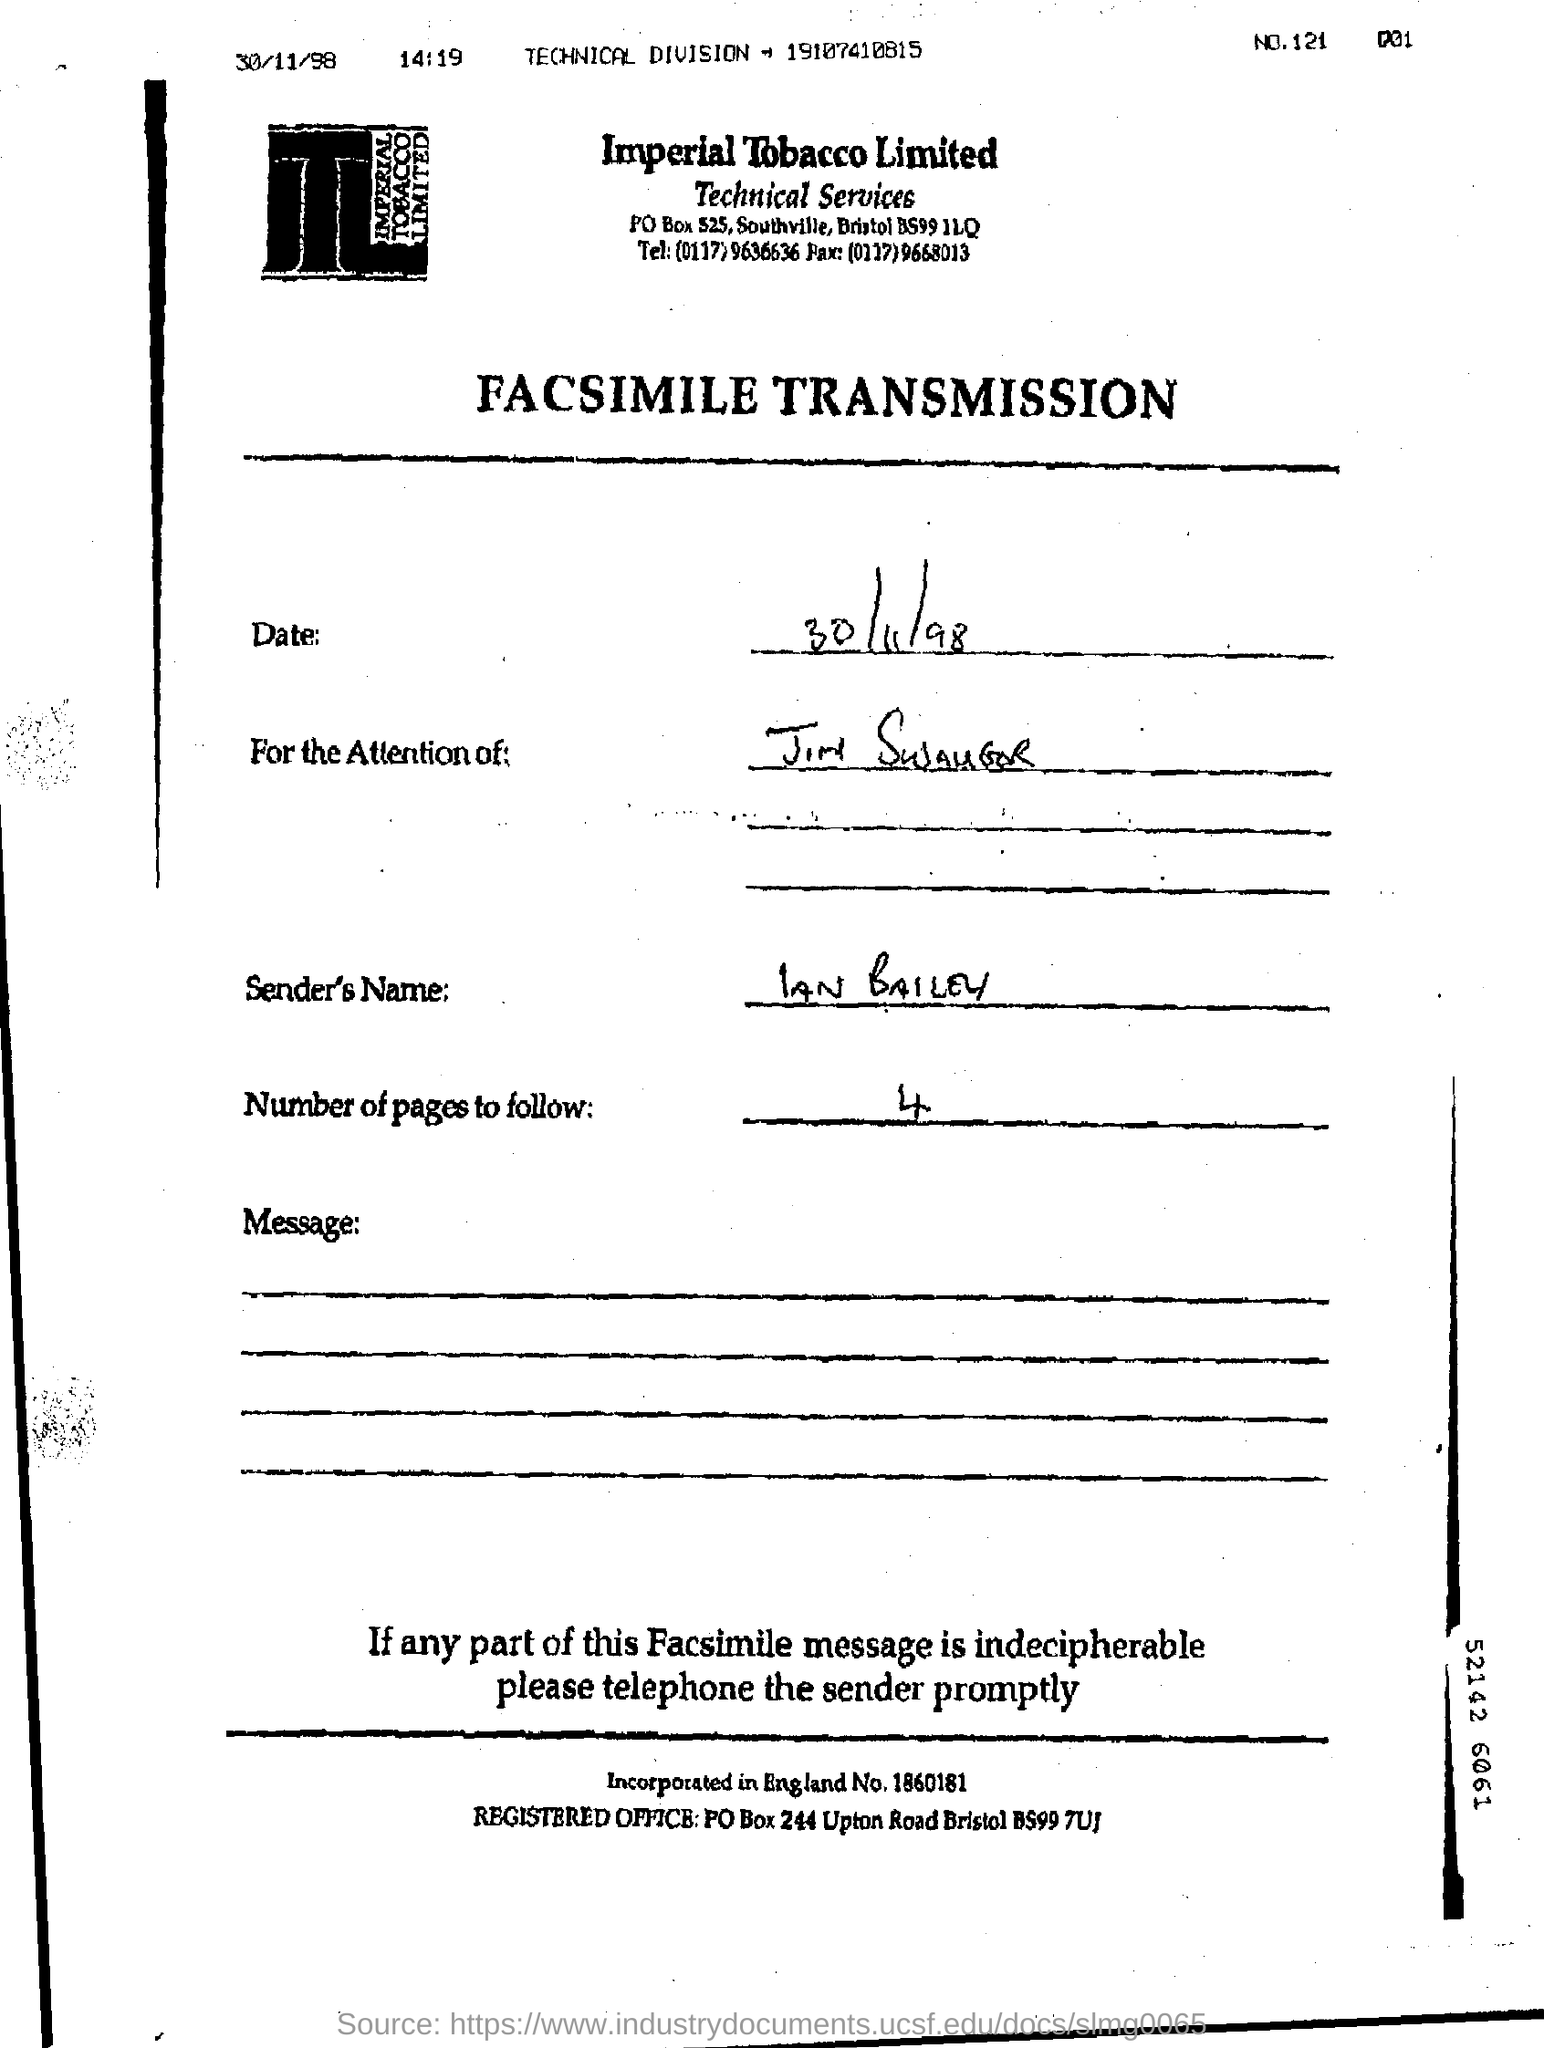Mention a couple of crucial points in this snapshot. The sender's name is IAN BAILEY. There are four pages to follow. Imperial Tobacco Limited is the company whose name appears at the top of the page. On what date is the information provided? The date is 30th November 1998. This is a facsimile transmission document. 